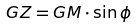<formula> <loc_0><loc_0><loc_500><loc_500>G Z = G M \cdot \sin \phi</formula> 